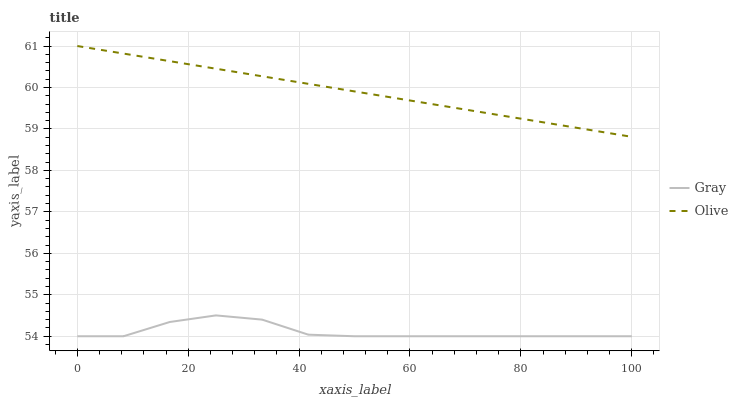Does Gray have the minimum area under the curve?
Answer yes or no. Yes. Does Olive have the maximum area under the curve?
Answer yes or no. Yes. Does Gray have the maximum area under the curve?
Answer yes or no. No. Is Olive the smoothest?
Answer yes or no. Yes. Is Gray the roughest?
Answer yes or no. Yes. Is Gray the smoothest?
Answer yes or no. No. Does Gray have the lowest value?
Answer yes or no. Yes. Does Olive have the highest value?
Answer yes or no. Yes. Does Gray have the highest value?
Answer yes or no. No. Is Gray less than Olive?
Answer yes or no. Yes. Is Olive greater than Gray?
Answer yes or no. Yes. Does Gray intersect Olive?
Answer yes or no. No. 